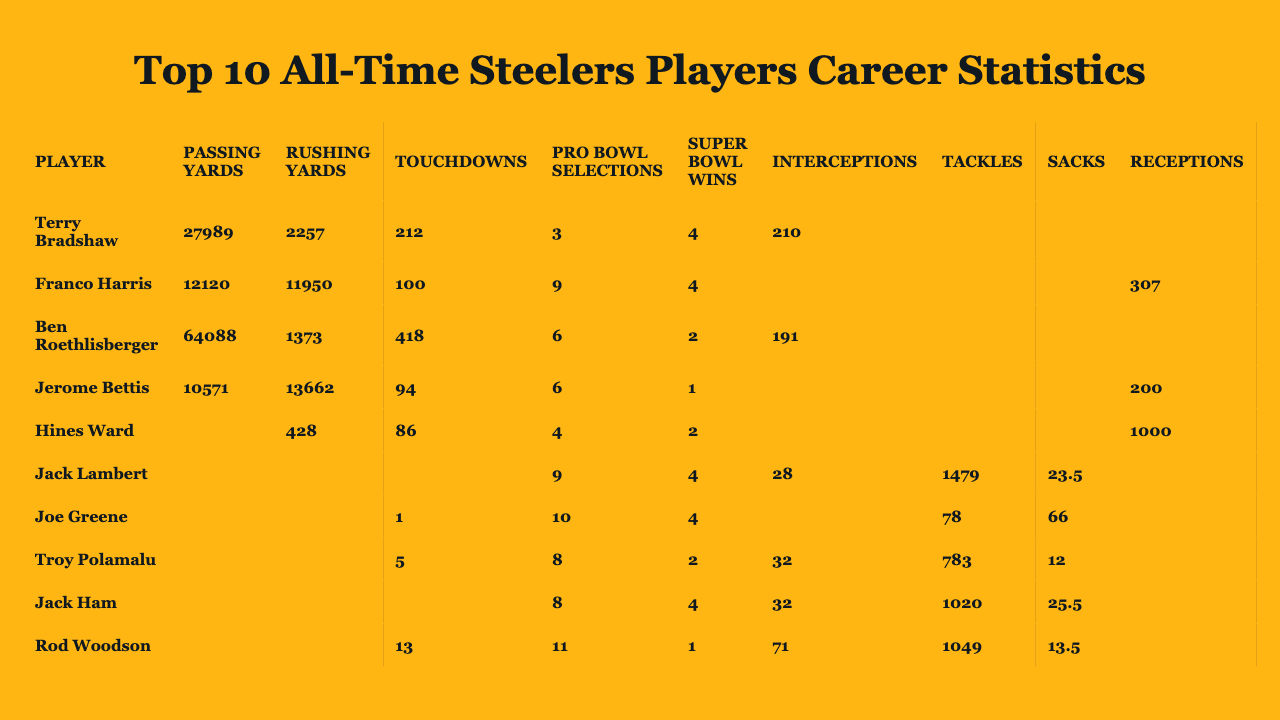What is the total number of Super Bowl wins by all players in the table? The Super Bowl wins for each player are 4, 4, 2, 1, 2, 4, 4, 2, 4, and 1. Adding these together: 4 + 4 + 2 + 1 + 2 + 4 + 4 + 2 + 4 + 1 = 24.
Answer: 24 Who has the highest passing yards? By looking at the passing yards column, Ben Roethlisberger has the highest value with 64,088 passing yards.
Answer: Ben Roethlisberger How many Pro Bowl selections does Terry Bradshaw have? The table shows that Terry Bradshaw has 3 Pro Bowl selections, as indicated in his row.
Answer: 3 Which player has the most touchdowns? By checking the touchdowns column, Ben Roethlisberger has the highest number with 418 touchdowns.
Answer: Ben Roethlisberger What is the average number of fumble recoveries among the players? The sum of fumble recoveries is 0 + 19 + 0 + 9 + 5 + 17 + 12 + 7 + 21 + 32 = 122. There are 10 players, so the average is 122 / 10 = 12.2.
Answer: 12.2 Did Hines Ward achieve any rushing yards? Looking at Hines Ward's row, he has 428 rushing yards, which is greater than 0.
Answer: Yes Which player has the lowest number of tackles? When reviewing the tackles column, Terry Bradshaw and Joe Greene both have 0 tackles, which is the lowest.
Answer: Terry Bradshaw and Joe Greene How many more Touchdowns does Ben Roethlisberger have compared to Terry Bradshaw? Ben Roethlisberger has 418 touchdowns and Terry Bradshaw has 212 touchdowns. The difference is 418 - 212 = 206.
Answer: 206 Who has the least number of receptions and how many are they? The least number of receptions in the table belong to Terry Bradshaw, who has 0 receptions.
Answer: Terry Bradshaw, 0 What is the total number of rushing yards for Franco Harris and Jerome Bettis combined? Franco Harris has 11,950 rushing yards and Jerome Bettis has 13,662 rushing yards. The total is 11,950 + 13,662 = 25,612 rushing yards.
Answer: 25,612 